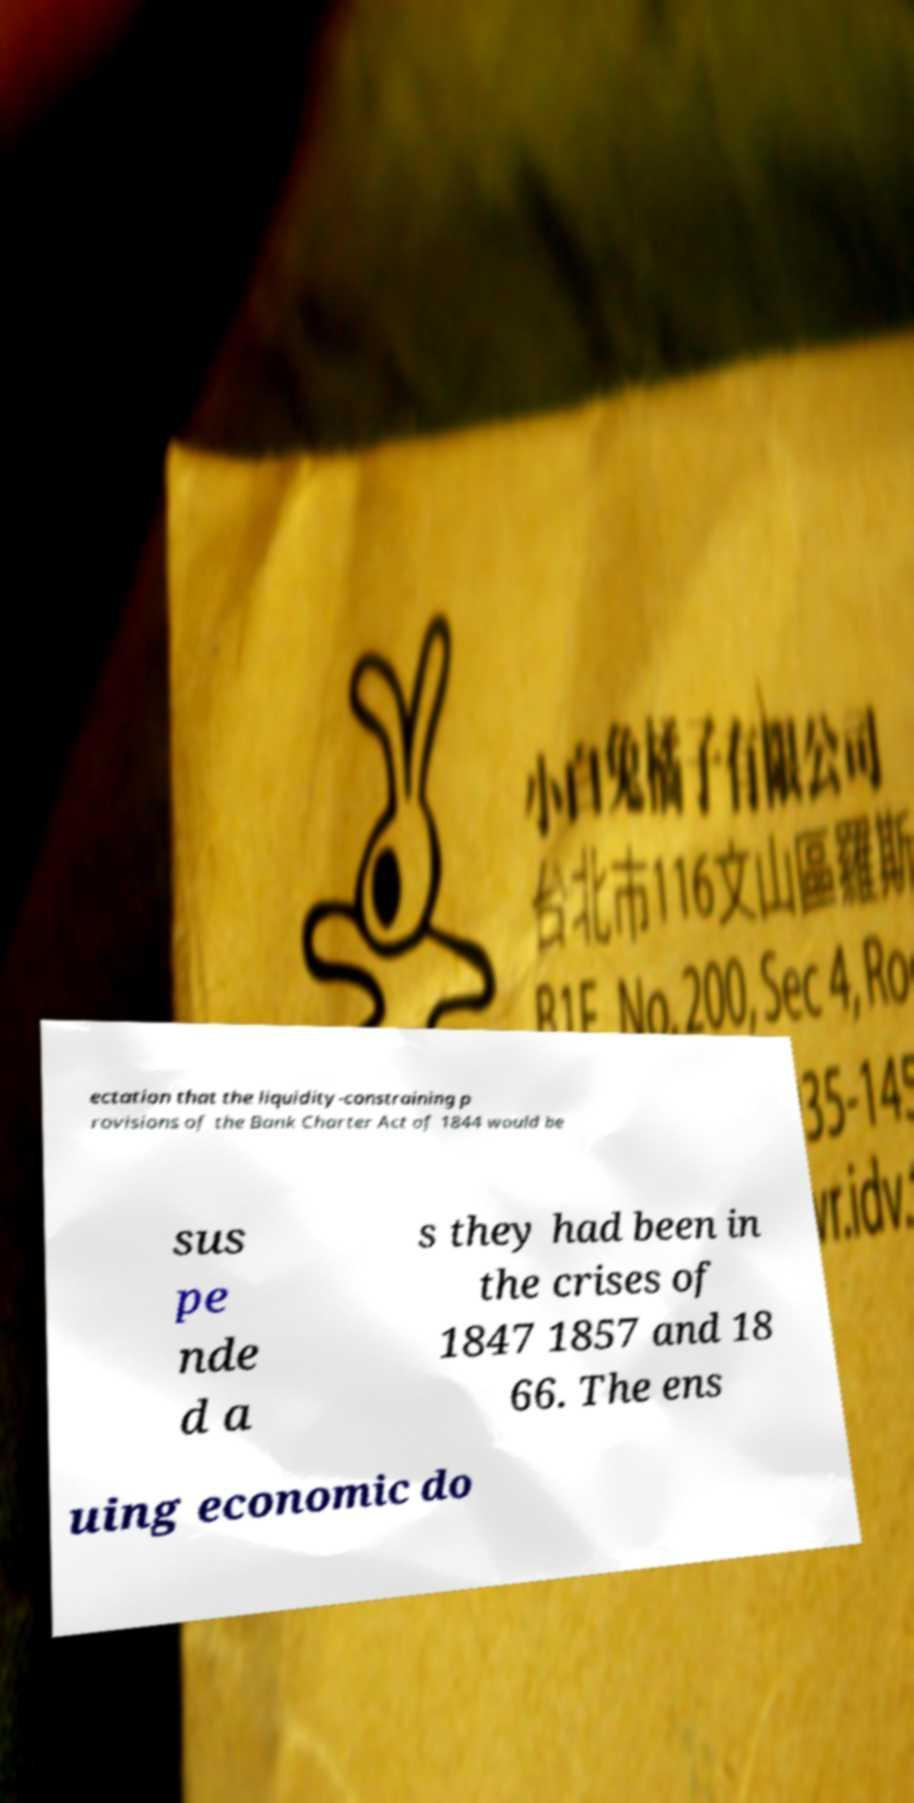For documentation purposes, I need the text within this image transcribed. Could you provide that? ectation that the liquidity-constraining p rovisions of the Bank Charter Act of 1844 would be sus pe nde d a s they had been in the crises of 1847 1857 and 18 66. The ens uing economic do 